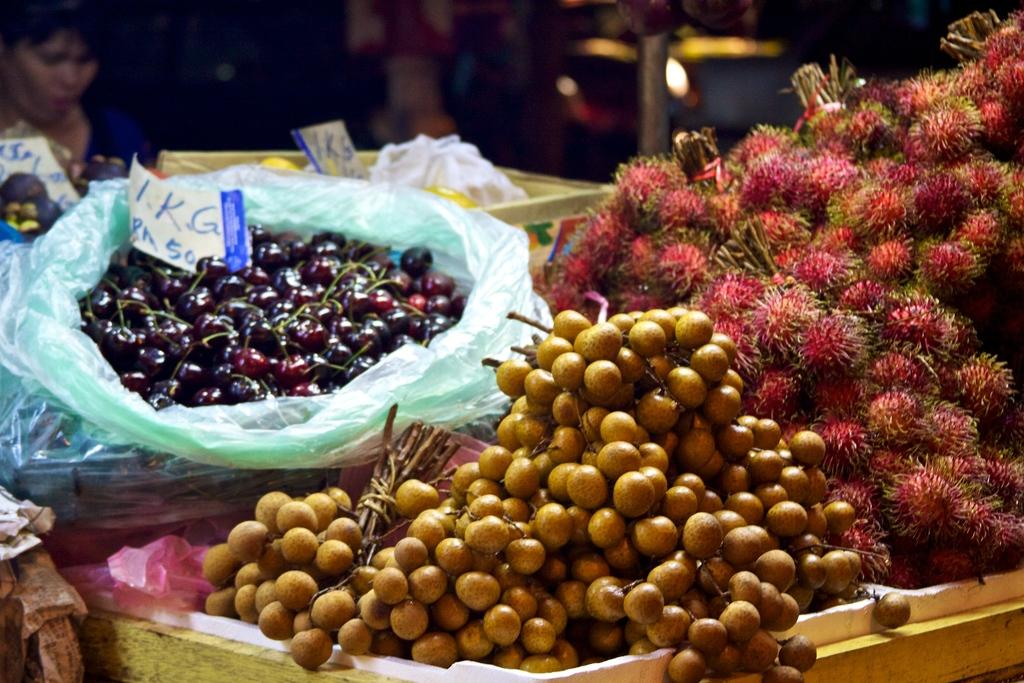What types of natural elements are present in the image? There are fruits and flowers in the image. Where are the fruits and flowers located? The fruits and flowers are on a table. Is there anyone in the image? Yes, there is a woman sitting in front of the table. What type of canvas is being used by the woman to paint in the image? There is no canvas or painting activity present in the image. Can you hear the sound of a bell in the image? There is no bell or any audible sound mentioned in the image. 